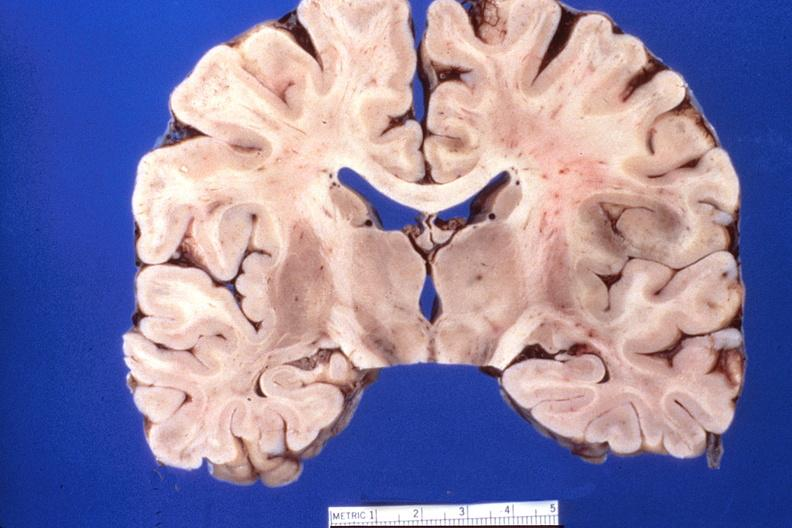s amyloidosis present?
Answer the question using a single word or phrase. No 